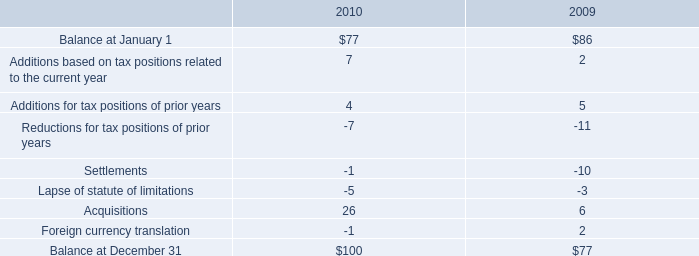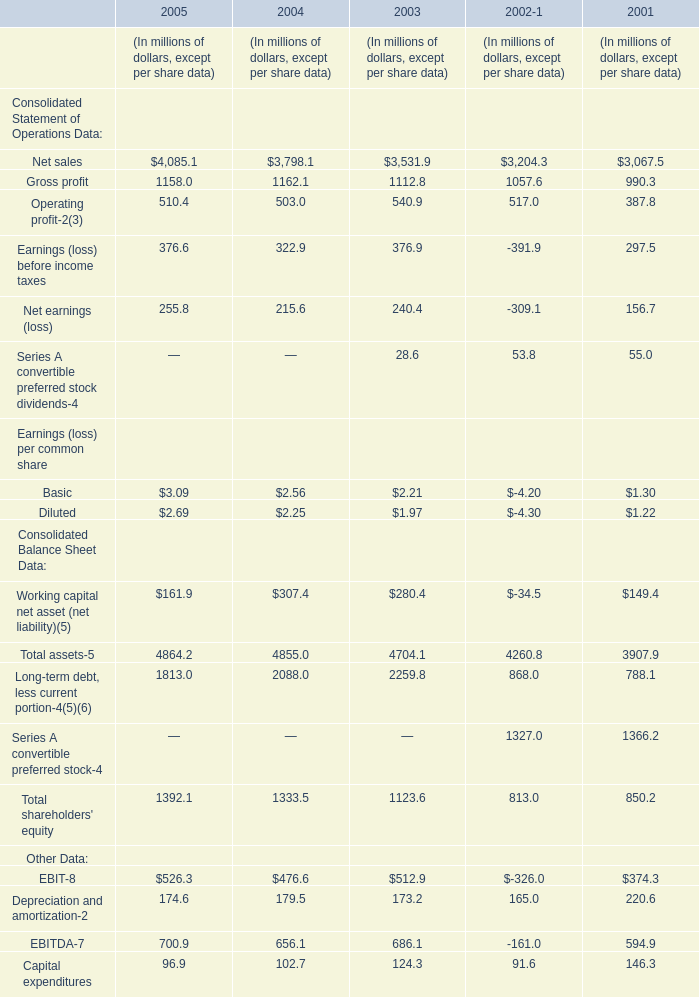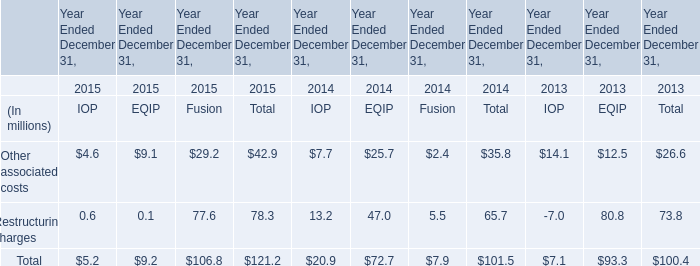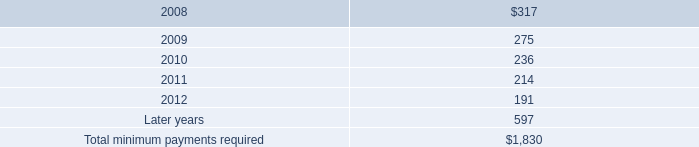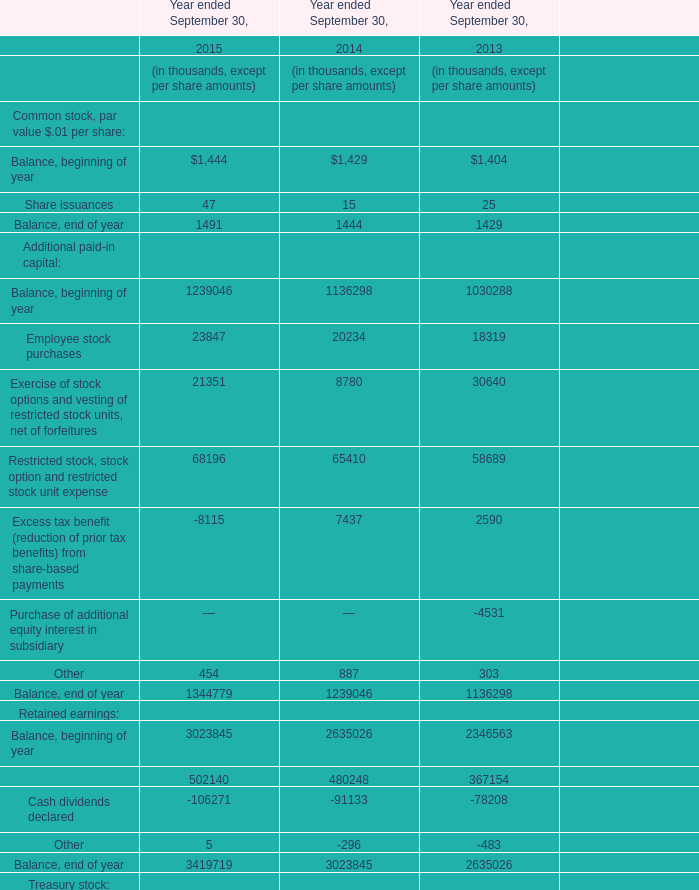What is the total value of Net sales, Gross profit, Operating profit-2(3) and Earnings (loss) before income taxes in 2005 ? (in million) 
Computations: ((((4085.1 + 1158) + 510.4) + 376.6) / 4)
Answer: 1532.525. 